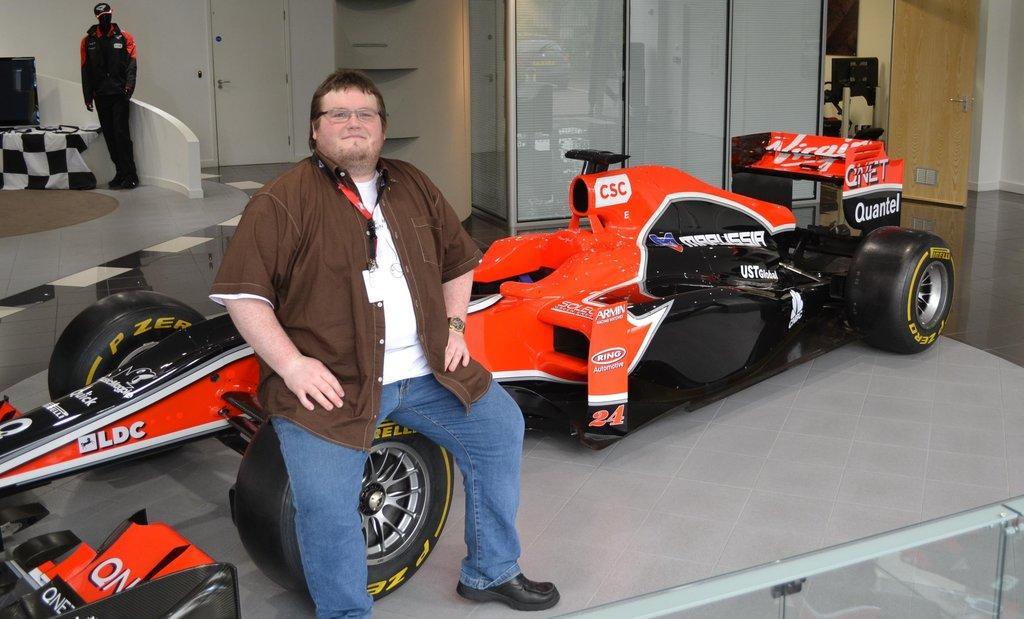Can you describe this image briefly? In this picture we can see a man wore a spectacle and smiling, vehicles on the floor, id card, mannequin, cap, jacket, television, cloth and in the background we can see doors, wall and some objects. 